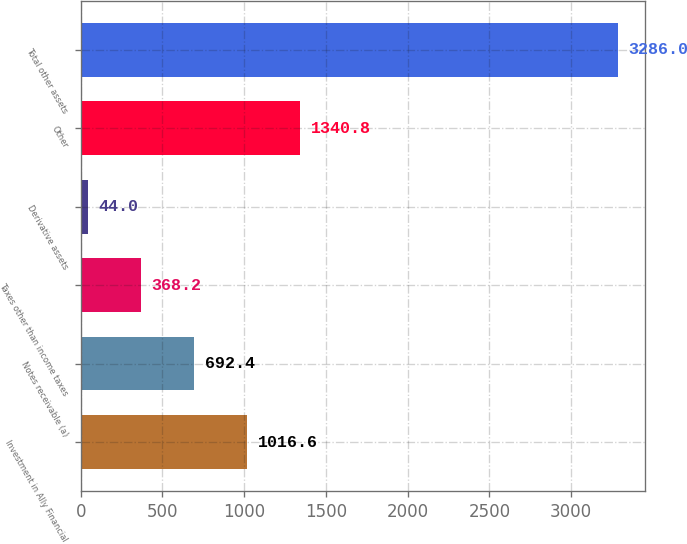Convert chart. <chart><loc_0><loc_0><loc_500><loc_500><bar_chart><fcel>Investment in Ally Financial<fcel>Notes receivable (a)<fcel>Taxes other than income taxes<fcel>Derivative assets<fcel>Other<fcel>Total other assets<nl><fcel>1016.6<fcel>692.4<fcel>368.2<fcel>44<fcel>1340.8<fcel>3286<nl></chart> 